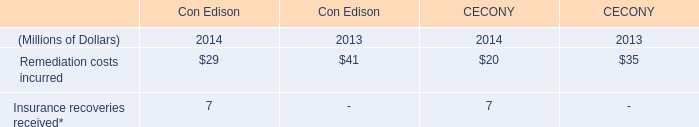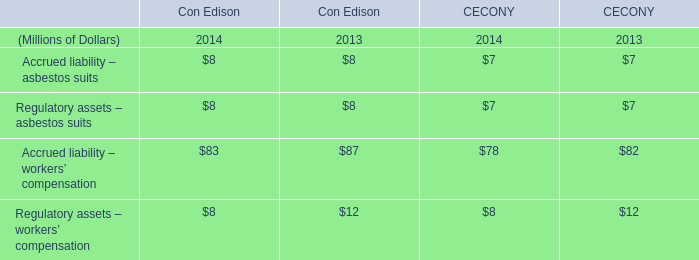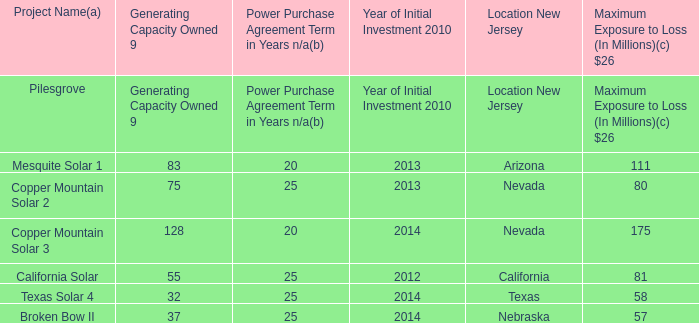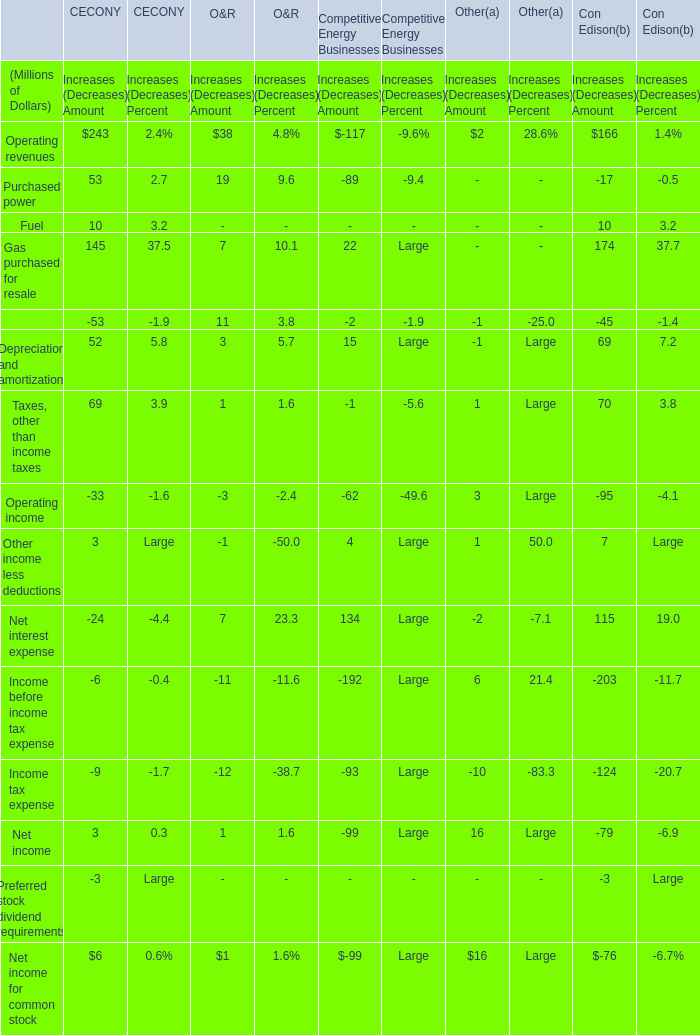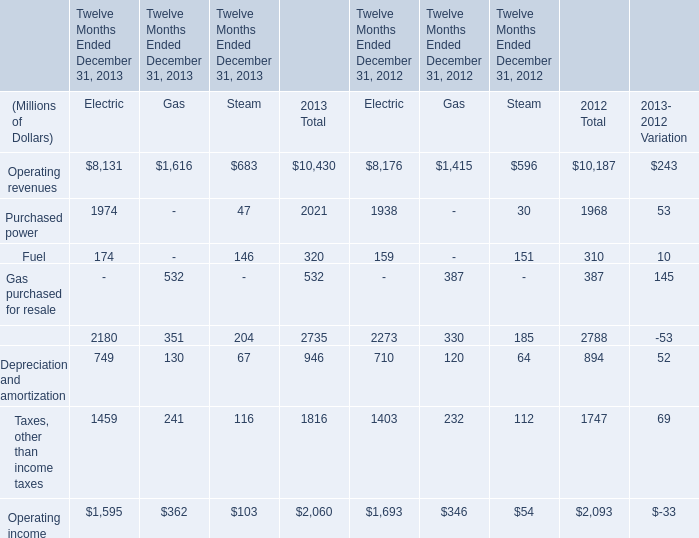In the year with largest value of operating revenues of gas, what's the sum of operating income of steam? (in million) 
Answer: 103. 